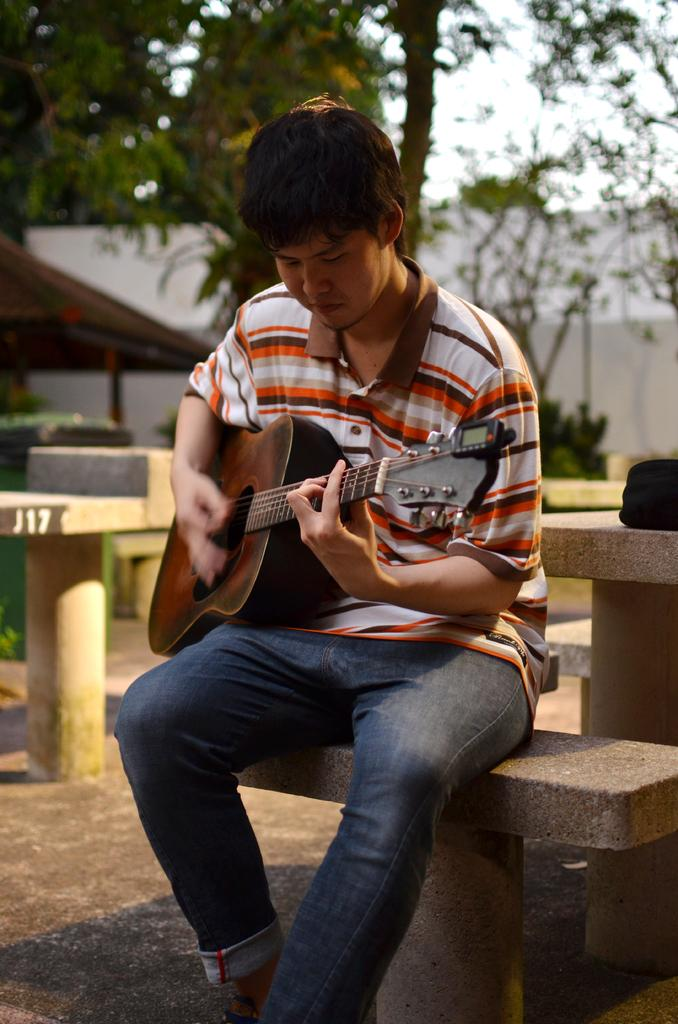What is the person in the image doing? The person is sitting on a chair and playing a guitar. What is the person wearing? The person is wearing a check shirt. What can be seen in the background of the image? There are trees, the sky, and a wall visible in the background. What type of sock is the person wearing in the image? There is no mention of socks in the image, so it cannot be determined what type of sock the person might be wearing. 